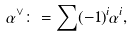<formula> <loc_0><loc_0><loc_500><loc_500>\alpha ^ { \vee } \colon = \sum ( - 1 ) ^ { i } \alpha ^ { i } ,</formula> 